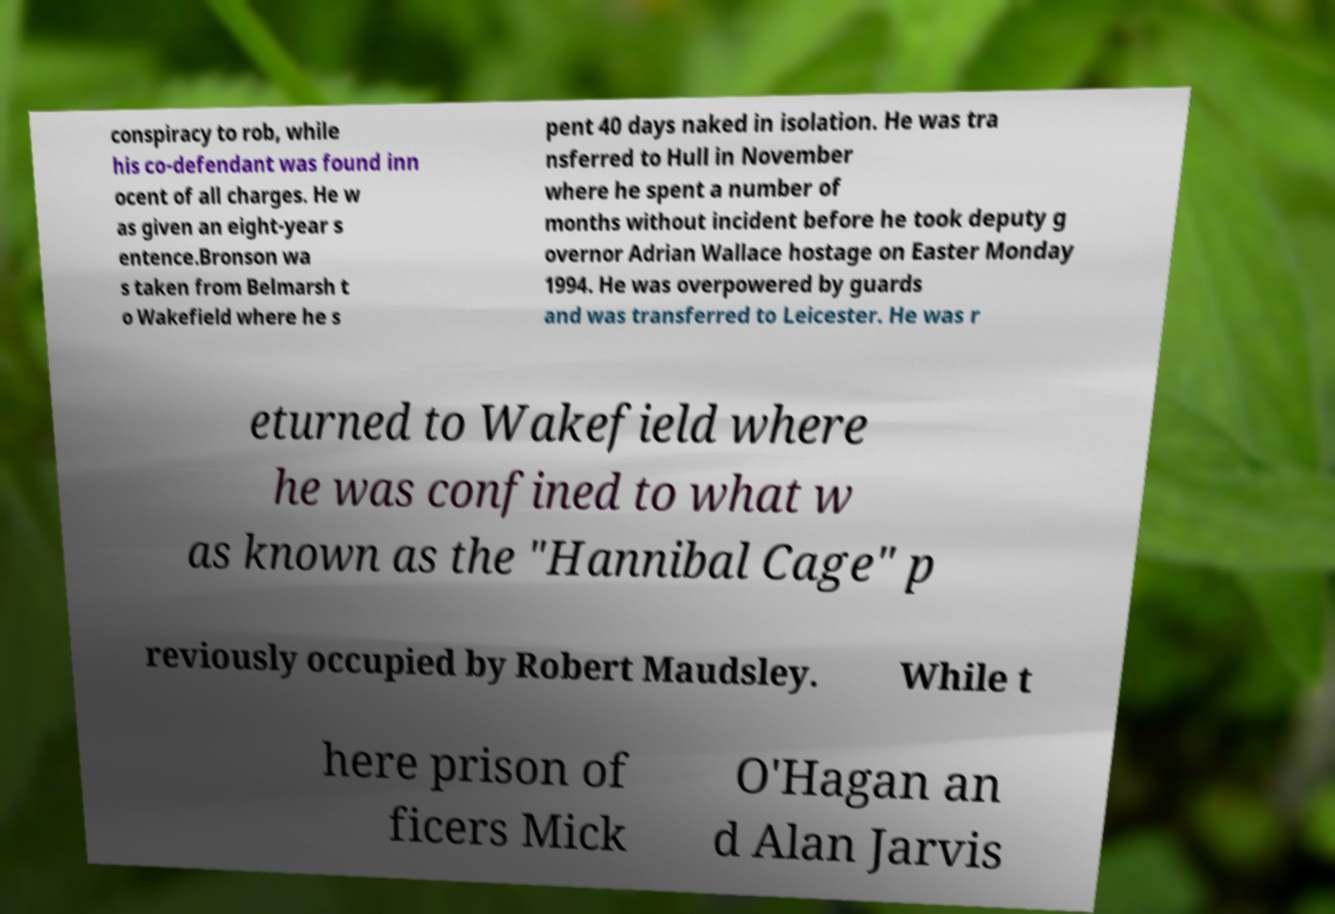Can you read and provide the text displayed in the image?This photo seems to have some interesting text. Can you extract and type it out for me? conspiracy to rob, while his co-defendant was found inn ocent of all charges. He w as given an eight-year s entence.Bronson wa s taken from Belmarsh t o Wakefield where he s pent 40 days naked in isolation. He was tra nsferred to Hull in November where he spent a number of months without incident before he took deputy g overnor Adrian Wallace hostage on Easter Monday 1994. He was overpowered by guards and was transferred to Leicester. He was r eturned to Wakefield where he was confined to what w as known as the "Hannibal Cage" p reviously occupied by Robert Maudsley. While t here prison of ficers Mick O'Hagan an d Alan Jarvis 